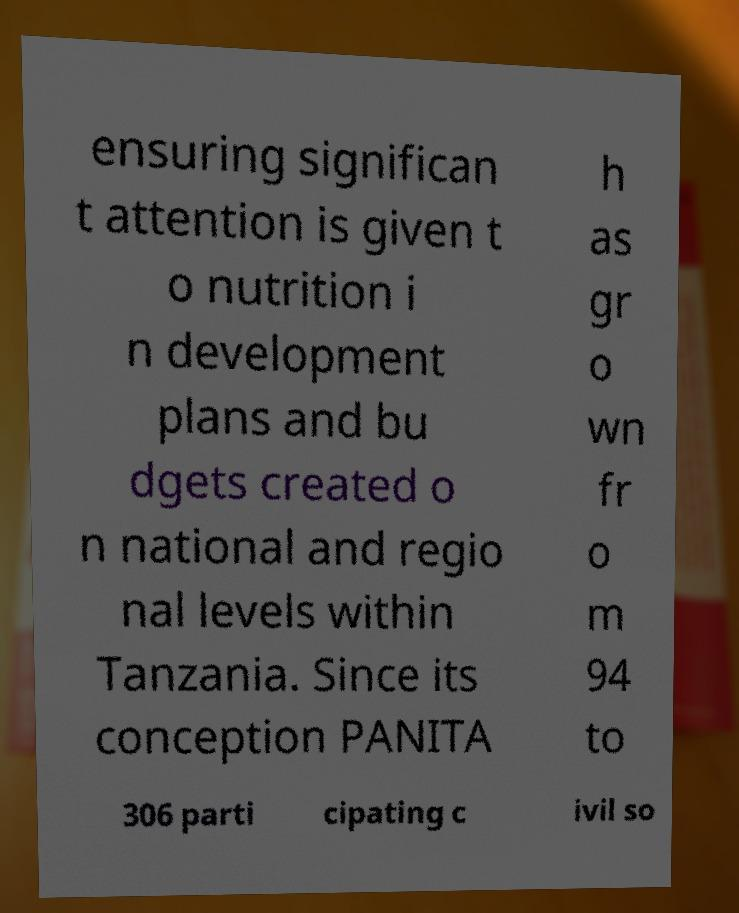Please read and relay the text visible in this image. What does it say? ensuring significan t attention is given t o nutrition i n development plans and bu dgets created o n national and regio nal levels within Tanzania. Since its conception PANITA h as gr o wn fr o m 94 to 306 parti cipating c ivil so 